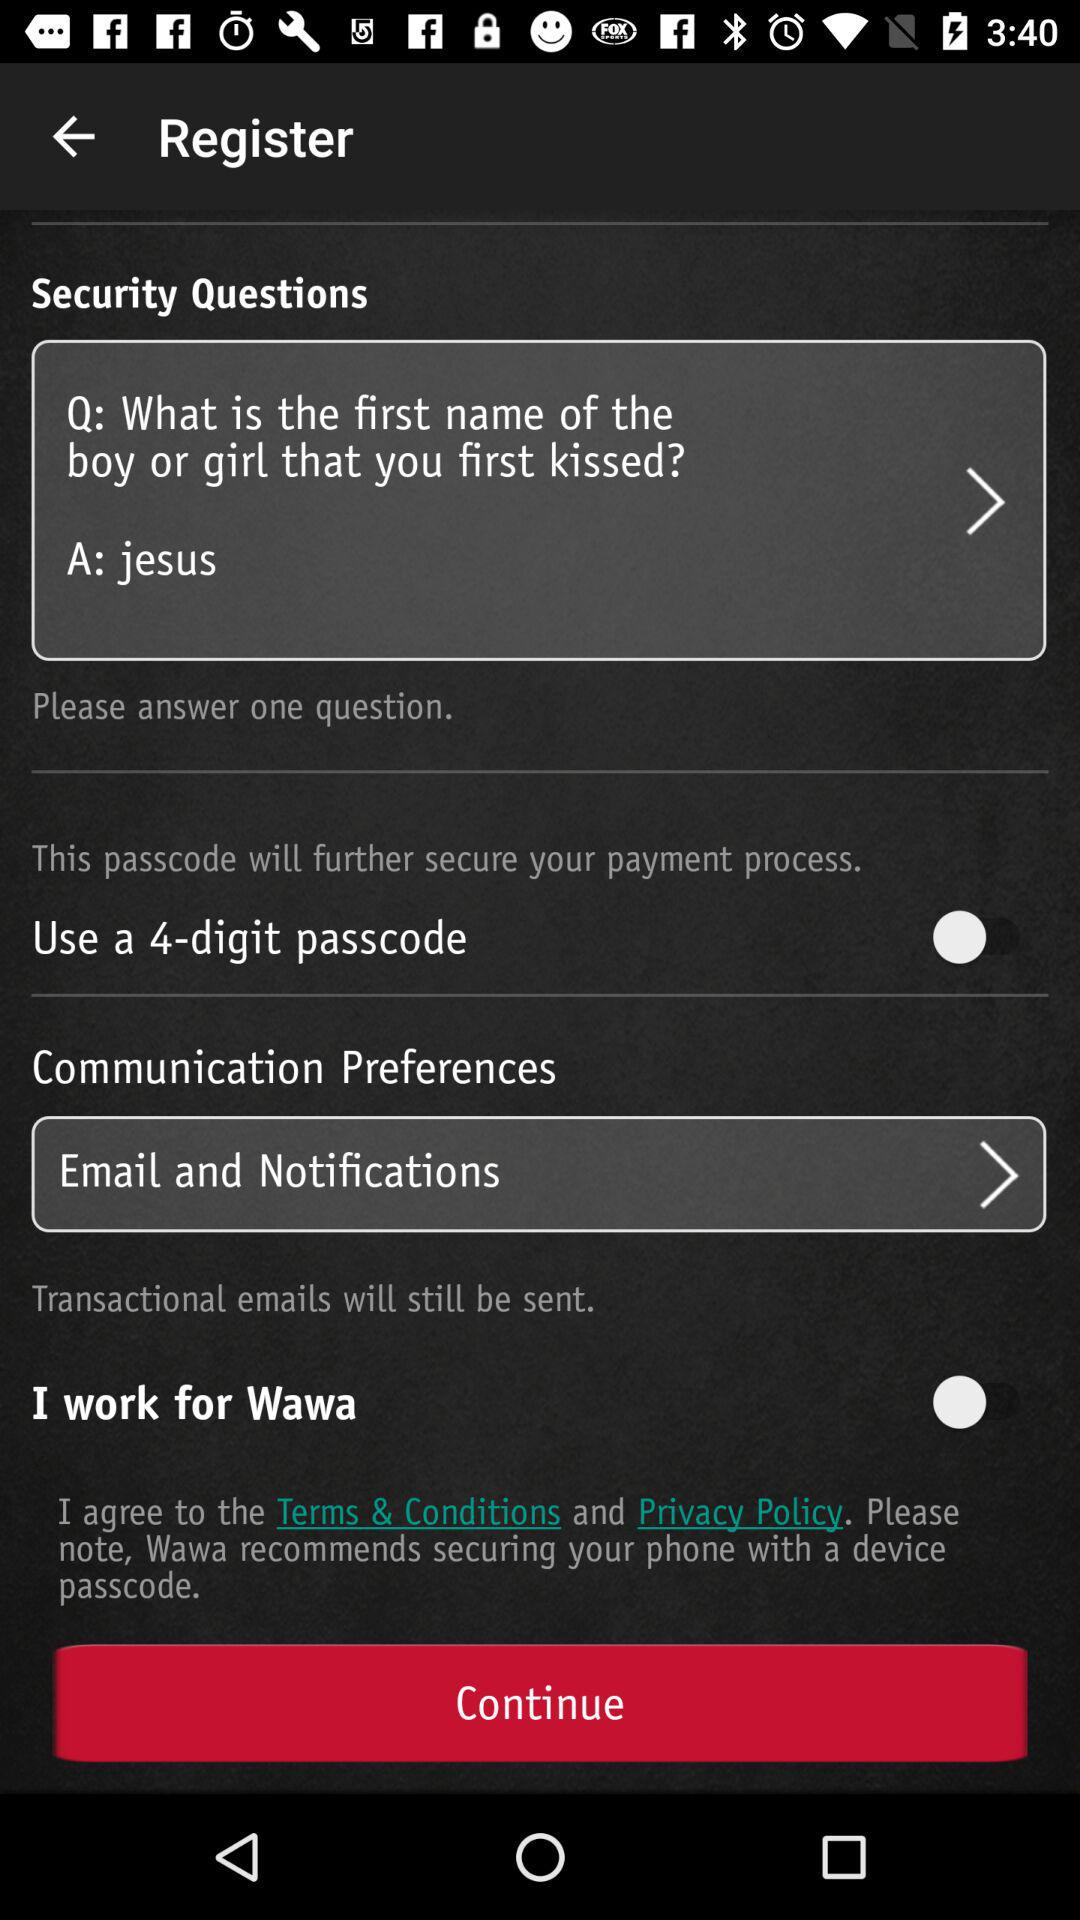How many security questions are there?
Answer the question using a single word or phrase. 1 